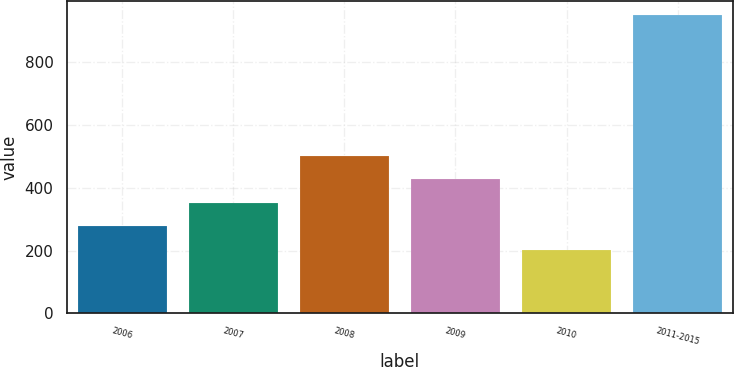Convert chart. <chart><loc_0><loc_0><loc_500><loc_500><bar_chart><fcel>2006<fcel>2007<fcel>2008<fcel>2009<fcel>2010<fcel>2011-2015<nl><fcel>277.7<fcel>352.4<fcel>501.8<fcel>427.1<fcel>203<fcel>950<nl></chart> 